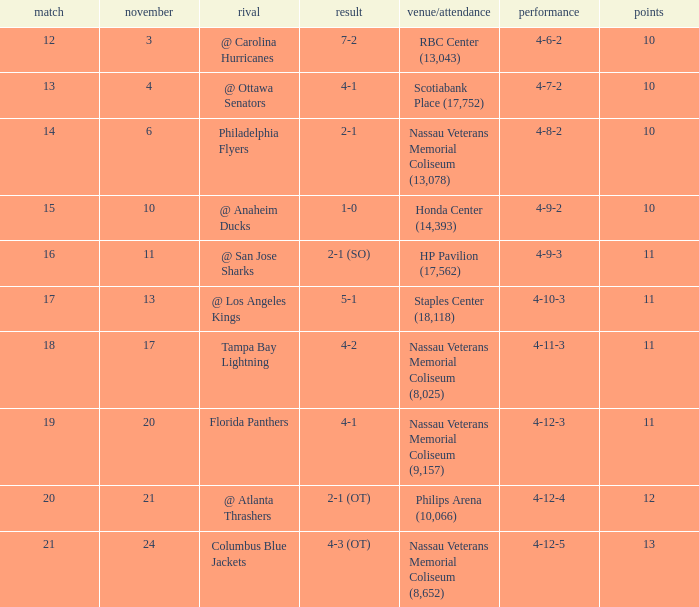What is the highest entry in November for the game 20? 21.0. 